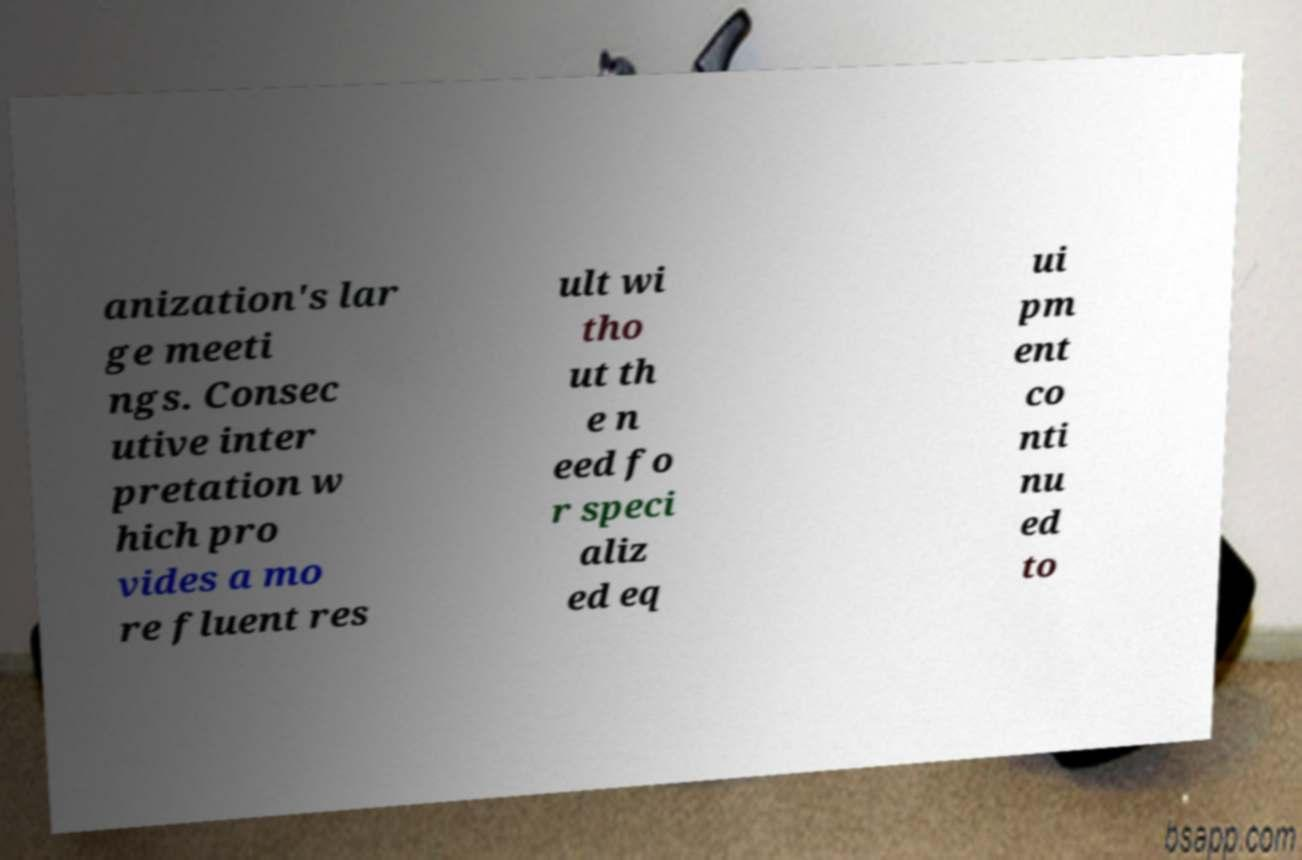Could you extract and type out the text from this image? anization's lar ge meeti ngs. Consec utive inter pretation w hich pro vides a mo re fluent res ult wi tho ut th e n eed fo r speci aliz ed eq ui pm ent co nti nu ed to 